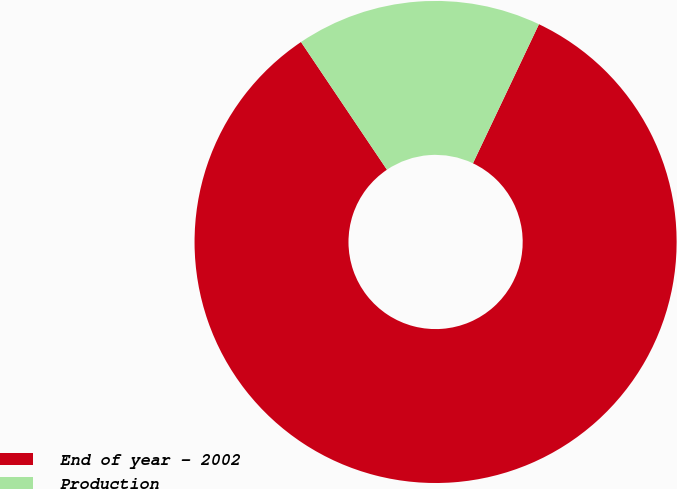Convert chart to OTSL. <chart><loc_0><loc_0><loc_500><loc_500><pie_chart><fcel>End of year - 2002<fcel>Production<nl><fcel>83.52%<fcel>16.48%<nl></chart> 